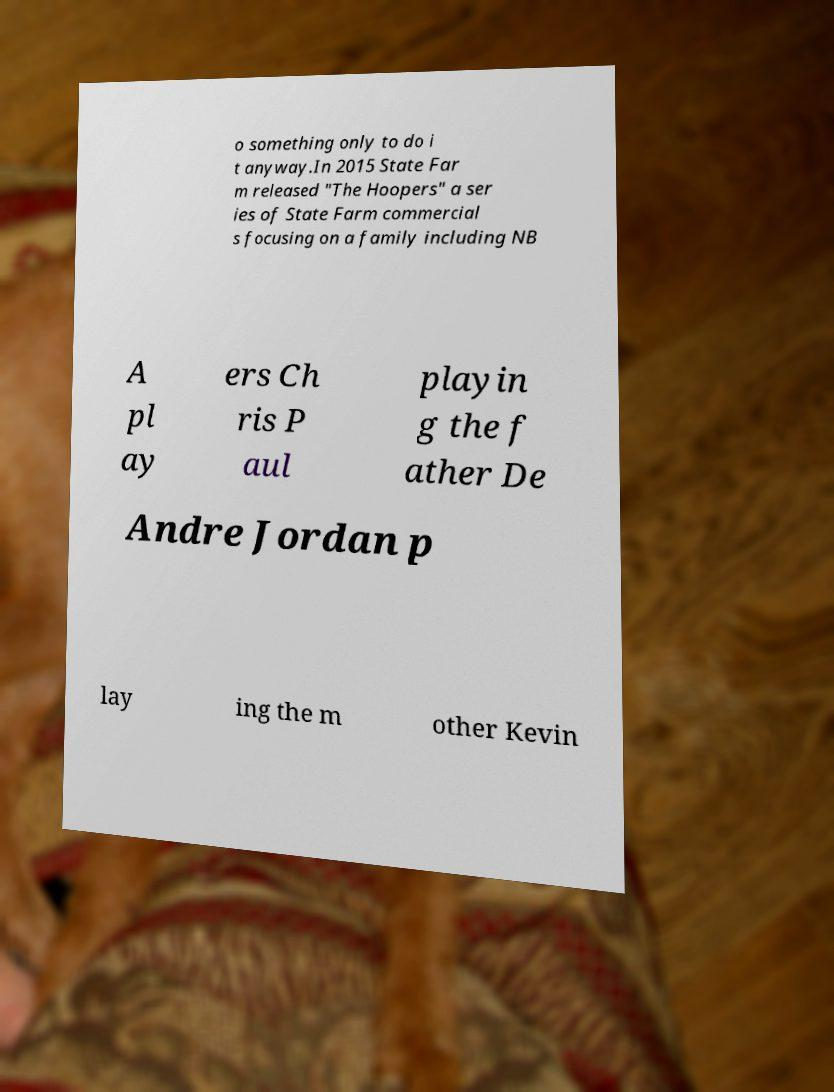Please read and relay the text visible in this image. What does it say? o something only to do i t anyway.In 2015 State Far m released "The Hoopers" a ser ies of State Farm commercial s focusing on a family including NB A pl ay ers Ch ris P aul playin g the f ather De Andre Jordan p lay ing the m other Kevin 